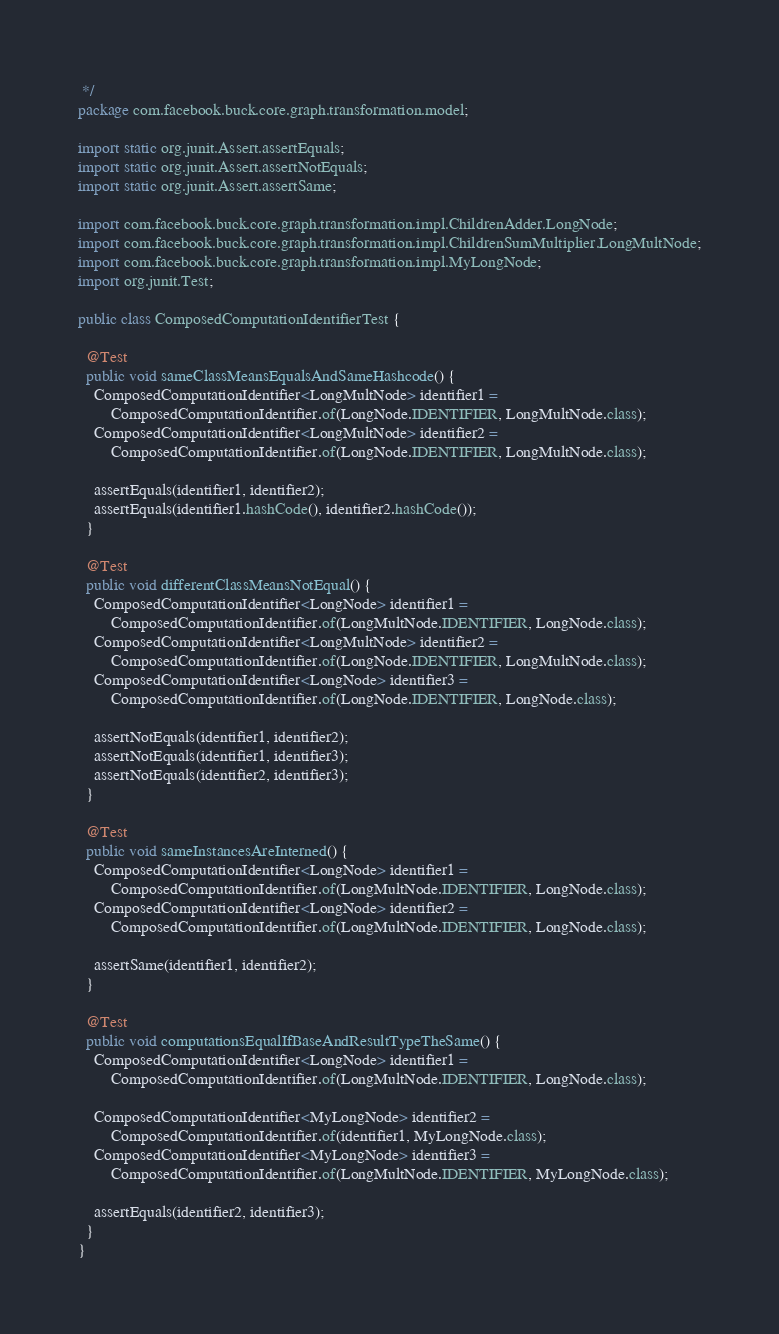<code> <loc_0><loc_0><loc_500><loc_500><_Java_> */
package com.facebook.buck.core.graph.transformation.model;

import static org.junit.Assert.assertEquals;
import static org.junit.Assert.assertNotEquals;
import static org.junit.Assert.assertSame;

import com.facebook.buck.core.graph.transformation.impl.ChildrenAdder.LongNode;
import com.facebook.buck.core.graph.transformation.impl.ChildrenSumMultiplier.LongMultNode;
import com.facebook.buck.core.graph.transformation.impl.MyLongNode;
import org.junit.Test;

public class ComposedComputationIdentifierTest {

  @Test
  public void sameClassMeansEqualsAndSameHashcode() {
    ComposedComputationIdentifier<LongMultNode> identifier1 =
        ComposedComputationIdentifier.of(LongNode.IDENTIFIER, LongMultNode.class);
    ComposedComputationIdentifier<LongMultNode> identifier2 =
        ComposedComputationIdentifier.of(LongNode.IDENTIFIER, LongMultNode.class);

    assertEquals(identifier1, identifier2);
    assertEquals(identifier1.hashCode(), identifier2.hashCode());
  }

  @Test
  public void differentClassMeansNotEqual() {
    ComposedComputationIdentifier<LongNode> identifier1 =
        ComposedComputationIdentifier.of(LongMultNode.IDENTIFIER, LongNode.class);
    ComposedComputationIdentifier<LongMultNode> identifier2 =
        ComposedComputationIdentifier.of(LongNode.IDENTIFIER, LongMultNode.class);
    ComposedComputationIdentifier<LongNode> identifier3 =
        ComposedComputationIdentifier.of(LongNode.IDENTIFIER, LongNode.class);

    assertNotEquals(identifier1, identifier2);
    assertNotEquals(identifier1, identifier3);
    assertNotEquals(identifier2, identifier3);
  }

  @Test
  public void sameInstancesAreInterned() {
    ComposedComputationIdentifier<LongNode> identifier1 =
        ComposedComputationIdentifier.of(LongMultNode.IDENTIFIER, LongNode.class);
    ComposedComputationIdentifier<LongNode> identifier2 =
        ComposedComputationIdentifier.of(LongMultNode.IDENTIFIER, LongNode.class);

    assertSame(identifier1, identifier2);
  }

  @Test
  public void computationsEqualIfBaseAndResultTypeTheSame() {
    ComposedComputationIdentifier<LongNode> identifier1 =
        ComposedComputationIdentifier.of(LongMultNode.IDENTIFIER, LongNode.class);

    ComposedComputationIdentifier<MyLongNode> identifier2 =
        ComposedComputationIdentifier.of(identifier1, MyLongNode.class);
    ComposedComputationIdentifier<MyLongNode> identifier3 =
        ComposedComputationIdentifier.of(LongMultNode.IDENTIFIER, MyLongNode.class);

    assertEquals(identifier2, identifier3);
  }
}
</code> 